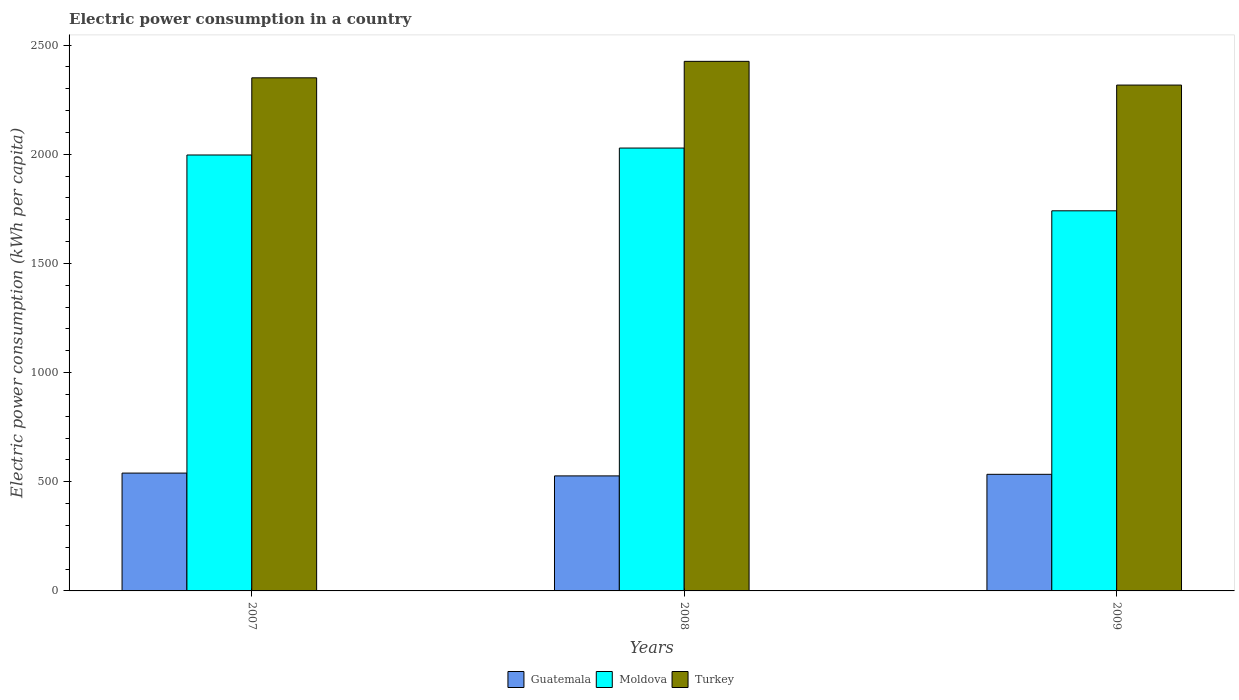How many different coloured bars are there?
Offer a very short reply. 3. Are the number of bars per tick equal to the number of legend labels?
Make the answer very short. Yes. Are the number of bars on each tick of the X-axis equal?
Provide a succinct answer. Yes. How many bars are there on the 2nd tick from the left?
Your answer should be compact. 3. How many bars are there on the 3rd tick from the right?
Provide a short and direct response. 3. In how many cases, is the number of bars for a given year not equal to the number of legend labels?
Your answer should be very brief. 0. What is the electric power consumption in in Moldova in 2007?
Make the answer very short. 1996.42. Across all years, what is the maximum electric power consumption in in Turkey?
Your answer should be very brief. 2425.27. Across all years, what is the minimum electric power consumption in in Turkey?
Offer a very short reply. 2316.64. In which year was the electric power consumption in in Turkey minimum?
Ensure brevity in your answer.  2009. What is the total electric power consumption in in Turkey in the graph?
Provide a short and direct response. 7091.79. What is the difference between the electric power consumption in in Turkey in 2008 and that in 2009?
Your answer should be compact. 108.63. What is the difference between the electric power consumption in in Moldova in 2008 and the electric power consumption in in Turkey in 2007?
Give a very brief answer. -321.65. What is the average electric power consumption in in Guatemala per year?
Ensure brevity in your answer.  533.47. In the year 2009, what is the difference between the electric power consumption in in Turkey and electric power consumption in in Guatemala?
Your response must be concise. 1782.66. In how many years, is the electric power consumption in in Moldova greater than 1200 kWh per capita?
Offer a terse response. 3. What is the ratio of the electric power consumption in in Guatemala in 2007 to that in 2008?
Keep it short and to the point. 1.02. Is the electric power consumption in in Turkey in 2008 less than that in 2009?
Provide a succinct answer. No. What is the difference between the highest and the second highest electric power consumption in in Moldova?
Your answer should be very brief. 31.81. What is the difference between the highest and the lowest electric power consumption in in Moldova?
Your answer should be compact. 287.43. In how many years, is the electric power consumption in in Guatemala greater than the average electric power consumption in in Guatemala taken over all years?
Your answer should be very brief. 2. What does the 1st bar from the left in 2007 represents?
Your answer should be very brief. Guatemala. What does the 2nd bar from the right in 2007 represents?
Keep it short and to the point. Moldova. Are all the bars in the graph horizontal?
Offer a very short reply. No. Are the values on the major ticks of Y-axis written in scientific E-notation?
Your response must be concise. No. Does the graph contain grids?
Provide a succinct answer. No. How many legend labels are there?
Provide a short and direct response. 3. How are the legend labels stacked?
Your response must be concise. Horizontal. What is the title of the graph?
Offer a terse response. Electric power consumption in a country. What is the label or title of the Y-axis?
Your response must be concise. Electric power consumption (kWh per capita). What is the Electric power consumption (kWh per capita) in Guatemala in 2007?
Provide a succinct answer. 539.66. What is the Electric power consumption (kWh per capita) of Moldova in 2007?
Make the answer very short. 1996.42. What is the Electric power consumption (kWh per capita) in Turkey in 2007?
Your response must be concise. 2349.88. What is the Electric power consumption (kWh per capita) of Guatemala in 2008?
Offer a terse response. 526.77. What is the Electric power consumption (kWh per capita) in Moldova in 2008?
Offer a very short reply. 2028.23. What is the Electric power consumption (kWh per capita) in Turkey in 2008?
Your answer should be compact. 2425.27. What is the Electric power consumption (kWh per capita) in Guatemala in 2009?
Provide a short and direct response. 533.98. What is the Electric power consumption (kWh per capita) in Moldova in 2009?
Make the answer very short. 1740.8. What is the Electric power consumption (kWh per capita) in Turkey in 2009?
Keep it short and to the point. 2316.64. Across all years, what is the maximum Electric power consumption (kWh per capita) of Guatemala?
Ensure brevity in your answer.  539.66. Across all years, what is the maximum Electric power consumption (kWh per capita) in Moldova?
Offer a very short reply. 2028.23. Across all years, what is the maximum Electric power consumption (kWh per capita) of Turkey?
Keep it short and to the point. 2425.27. Across all years, what is the minimum Electric power consumption (kWh per capita) in Guatemala?
Keep it short and to the point. 526.77. Across all years, what is the minimum Electric power consumption (kWh per capita) in Moldova?
Your response must be concise. 1740.8. Across all years, what is the minimum Electric power consumption (kWh per capita) of Turkey?
Your response must be concise. 2316.64. What is the total Electric power consumption (kWh per capita) of Guatemala in the graph?
Provide a short and direct response. 1600.41. What is the total Electric power consumption (kWh per capita) in Moldova in the graph?
Provide a succinct answer. 5765.44. What is the total Electric power consumption (kWh per capita) in Turkey in the graph?
Provide a short and direct response. 7091.79. What is the difference between the Electric power consumption (kWh per capita) in Guatemala in 2007 and that in 2008?
Your response must be concise. 12.89. What is the difference between the Electric power consumption (kWh per capita) in Moldova in 2007 and that in 2008?
Your answer should be compact. -31.81. What is the difference between the Electric power consumption (kWh per capita) of Turkey in 2007 and that in 2008?
Offer a terse response. -75.39. What is the difference between the Electric power consumption (kWh per capita) in Guatemala in 2007 and that in 2009?
Offer a very short reply. 5.67. What is the difference between the Electric power consumption (kWh per capita) in Moldova in 2007 and that in 2009?
Provide a short and direct response. 255.62. What is the difference between the Electric power consumption (kWh per capita) in Turkey in 2007 and that in 2009?
Offer a terse response. 33.24. What is the difference between the Electric power consumption (kWh per capita) in Guatemala in 2008 and that in 2009?
Provide a succinct answer. -7.21. What is the difference between the Electric power consumption (kWh per capita) of Moldova in 2008 and that in 2009?
Offer a terse response. 287.43. What is the difference between the Electric power consumption (kWh per capita) of Turkey in 2008 and that in 2009?
Provide a succinct answer. 108.63. What is the difference between the Electric power consumption (kWh per capita) in Guatemala in 2007 and the Electric power consumption (kWh per capita) in Moldova in 2008?
Your answer should be compact. -1488.57. What is the difference between the Electric power consumption (kWh per capita) in Guatemala in 2007 and the Electric power consumption (kWh per capita) in Turkey in 2008?
Offer a terse response. -1885.61. What is the difference between the Electric power consumption (kWh per capita) in Moldova in 2007 and the Electric power consumption (kWh per capita) in Turkey in 2008?
Offer a very short reply. -428.85. What is the difference between the Electric power consumption (kWh per capita) of Guatemala in 2007 and the Electric power consumption (kWh per capita) of Moldova in 2009?
Your answer should be compact. -1201.14. What is the difference between the Electric power consumption (kWh per capita) of Guatemala in 2007 and the Electric power consumption (kWh per capita) of Turkey in 2009?
Your answer should be very brief. -1776.98. What is the difference between the Electric power consumption (kWh per capita) in Moldova in 2007 and the Electric power consumption (kWh per capita) in Turkey in 2009?
Offer a terse response. -320.23. What is the difference between the Electric power consumption (kWh per capita) of Guatemala in 2008 and the Electric power consumption (kWh per capita) of Moldova in 2009?
Offer a very short reply. -1214.03. What is the difference between the Electric power consumption (kWh per capita) in Guatemala in 2008 and the Electric power consumption (kWh per capita) in Turkey in 2009?
Provide a short and direct response. -1789.87. What is the difference between the Electric power consumption (kWh per capita) of Moldova in 2008 and the Electric power consumption (kWh per capita) of Turkey in 2009?
Make the answer very short. -288.41. What is the average Electric power consumption (kWh per capita) in Guatemala per year?
Keep it short and to the point. 533.47. What is the average Electric power consumption (kWh per capita) of Moldova per year?
Your answer should be very brief. 1921.82. What is the average Electric power consumption (kWh per capita) in Turkey per year?
Ensure brevity in your answer.  2363.93. In the year 2007, what is the difference between the Electric power consumption (kWh per capita) of Guatemala and Electric power consumption (kWh per capita) of Moldova?
Keep it short and to the point. -1456.76. In the year 2007, what is the difference between the Electric power consumption (kWh per capita) in Guatemala and Electric power consumption (kWh per capita) in Turkey?
Your response must be concise. -1810.22. In the year 2007, what is the difference between the Electric power consumption (kWh per capita) in Moldova and Electric power consumption (kWh per capita) in Turkey?
Provide a succinct answer. -353.46. In the year 2008, what is the difference between the Electric power consumption (kWh per capita) in Guatemala and Electric power consumption (kWh per capita) in Moldova?
Your response must be concise. -1501.46. In the year 2008, what is the difference between the Electric power consumption (kWh per capita) in Guatemala and Electric power consumption (kWh per capita) in Turkey?
Your response must be concise. -1898.5. In the year 2008, what is the difference between the Electric power consumption (kWh per capita) of Moldova and Electric power consumption (kWh per capita) of Turkey?
Your answer should be very brief. -397.04. In the year 2009, what is the difference between the Electric power consumption (kWh per capita) of Guatemala and Electric power consumption (kWh per capita) of Moldova?
Give a very brief answer. -1206.82. In the year 2009, what is the difference between the Electric power consumption (kWh per capita) of Guatemala and Electric power consumption (kWh per capita) of Turkey?
Make the answer very short. -1782.66. In the year 2009, what is the difference between the Electric power consumption (kWh per capita) in Moldova and Electric power consumption (kWh per capita) in Turkey?
Keep it short and to the point. -575.84. What is the ratio of the Electric power consumption (kWh per capita) in Guatemala in 2007 to that in 2008?
Provide a short and direct response. 1.02. What is the ratio of the Electric power consumption (kWh per capita) in Moldova in 2007 to that in 2008?
Provide a short and direct response. 0.98. What is the ratio of the Electric power consumption (kWh per capita) of Turkey in 2007 to that in 2008?
Offer a very short reply. 0.97. What is the ratio of the Electric power consumption (kWh per capita) of Guatemala in 2007 to that in 2009?
Provide a succinct answer. 1.01. What is the ratio of the Electric power consumption (kWh per capita) in Moldova in 2007 to that in 2009?
Offer a very short reply. 1.15. What is the ratio of the Electric power consumption (kWh per capita) in Turkey in 2007 to that in 2009?
Your answer should be compact. 1.01. What is the ratio of the Electric power consumption (kWh per capita) in Guatemala in 2008 to that in 2009?
Offer a terse response. 0.99. What is the ratio of the Electric power consumption (kWh per capita) in Moldova in 2008 to that in 2009?
Your answer should be compact. 1.17. What is the ratio of the Electric power consumption (kWh per capita) in Turkey in 2008 to that in 2009?
Make the answer very short. 1.05. What is the difference between the highest and the second highest Electric power consumption (kWh per capita) in Guatemala?
Your answer should be compact. 5.67. What is the difference between the highest and the second highest Electric power consumption (kWh per capita) in Moldova?
Your response must be concise. 31.81. What is the difference between the highest and the second highest Electric power consumption (kWh per capita) in Turkey?
Give a very brief answer. 75.39. What is the difference between the highest and the lowest Electric power consumption (kWh per capita) in Guatemala?
Offer a very short reply. 12.89. What is the difference between the highest and the lowest Electric power consumption (kWh per capita) in Moldova?
Offer a terse response. 287.43. What is the difference between the highest and the lowest Electric power consumption (kWh per capita) in Turkey?
Give a very brief answer. 108.63. 